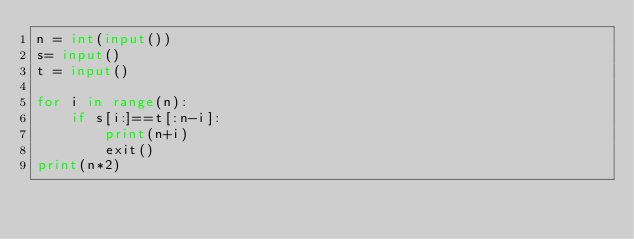Convert code to text. <code><loc_0><loc_0><loc_500><loc_500><_Python_>n = int(input())
s= input()
t = input()

for i in range(n):
    if s[i:]==t[:n-i]:
        print(n+i)
        exit()
print(n*2)</code> 